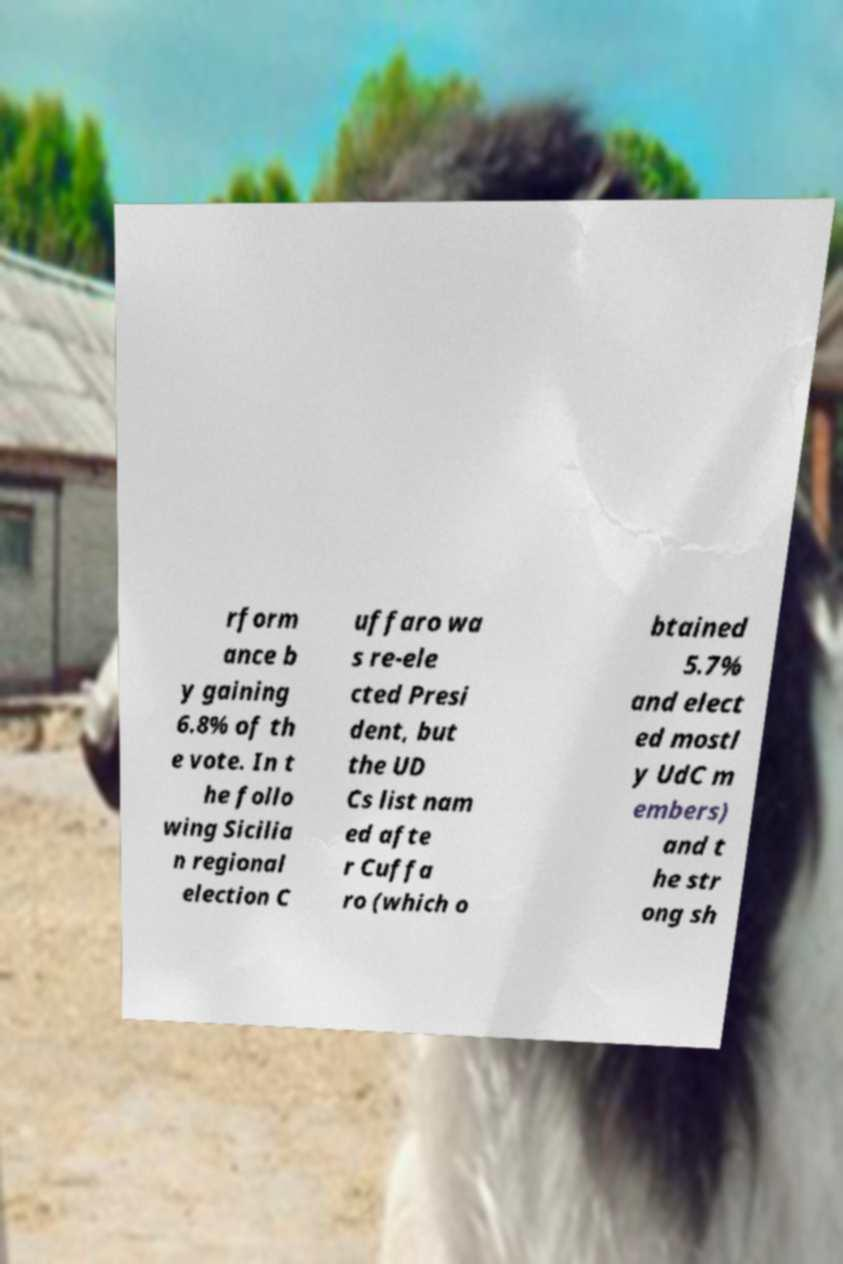Can you accurately transcribe the text from the provided image for me? rform ance b y gaining 6.8% of th e vote. In t he follo wing Sicilia n regional election C uffaro wa s re-ele cted Presi dent, but the UD Cs list nam ed afte r Cuffa ro (which o btained 5.7% and elect ed mostl y UdC m embers) and t he str ong sh 